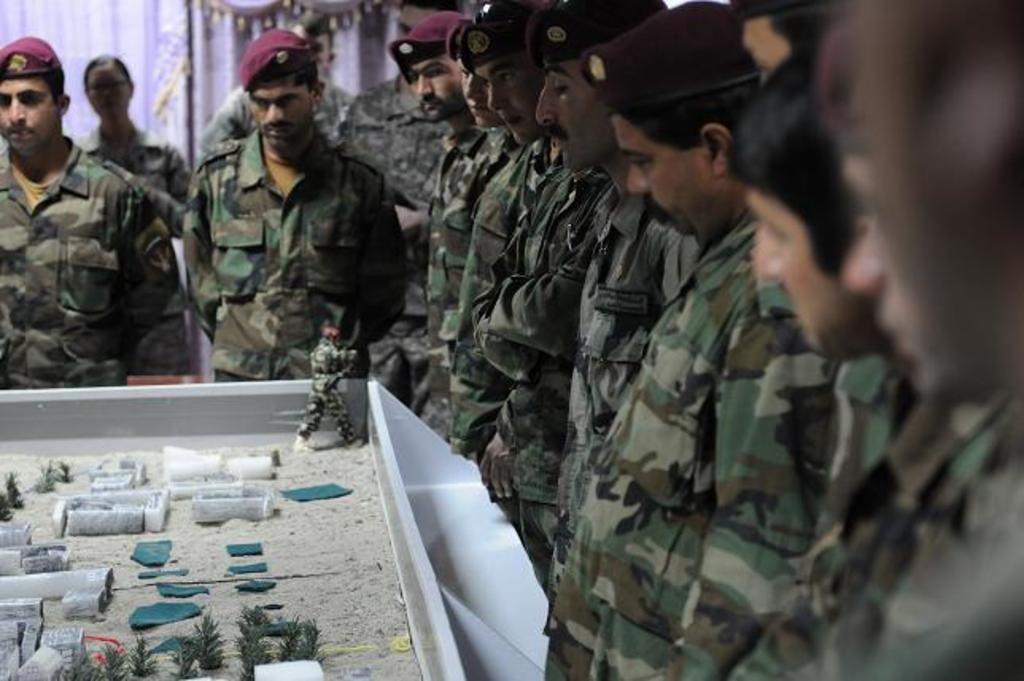How many people are in the image? There is a group of people in the image. What are the people in the group doing? The people are standing. What are some people in the group wearing on their heads? Some people in the group are wearing caps. What is the miniature object in front of the group? Unfortunately, the provided facts do not give any information about the miniature object. What type of wool is being used by the people in the image? There is no mention of wool in the image or the provided facts, so it cannot be determined what type of wool, if any, is being used. 